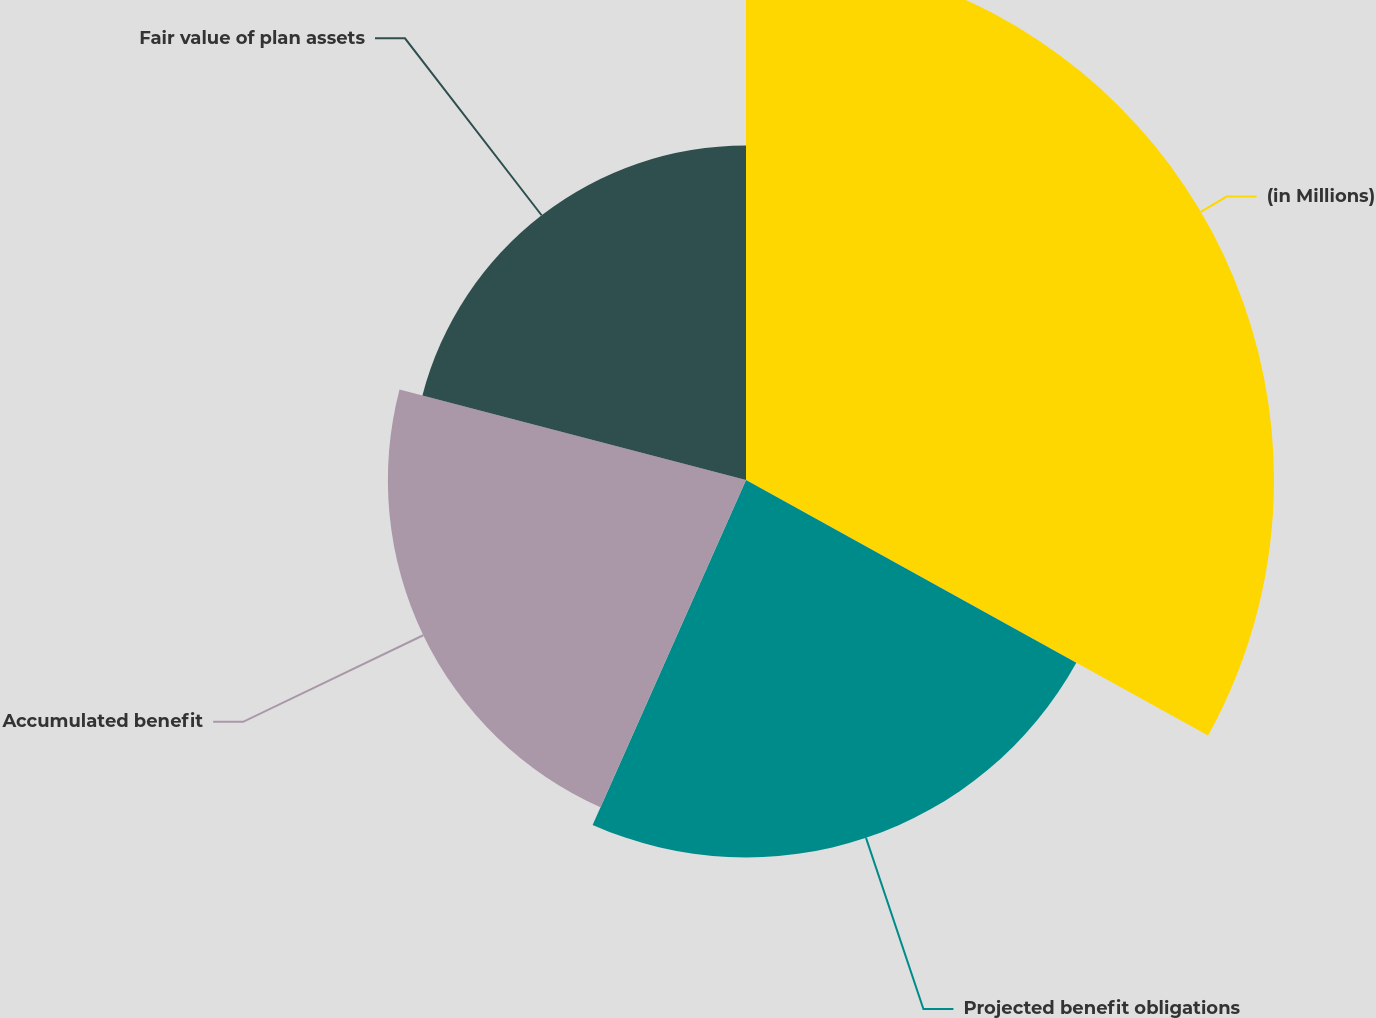<chart> <loc_0><loc_0><loc_500><loc_500><pie_chart><fcel>(in Millions)<fcel>Projected benefit obligations<fcel>Accumulated benefit<fcel>Fair value of plan assets<nl><fcel>33.04%<fcel>23.62%<fcel>22.41%<fcel>20.93%<nl></chart> 